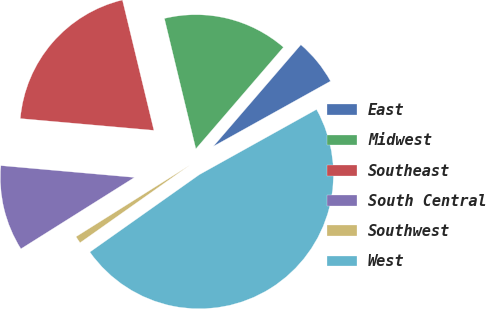Convert chart to OTSL. <chart><loc_0><loc_0><loc_500><loc_500><pie_chart><fcel>East<fcel>Midwest<fcel>Southeast<fcel>South Central<fcel>Southwest<fcel>West<nl><fcel>5.6%<fcel>15.09%<fcel>19.83%<fcel>10.34%<fcel>0.86%<fcel>48.29%<nl></chart> 